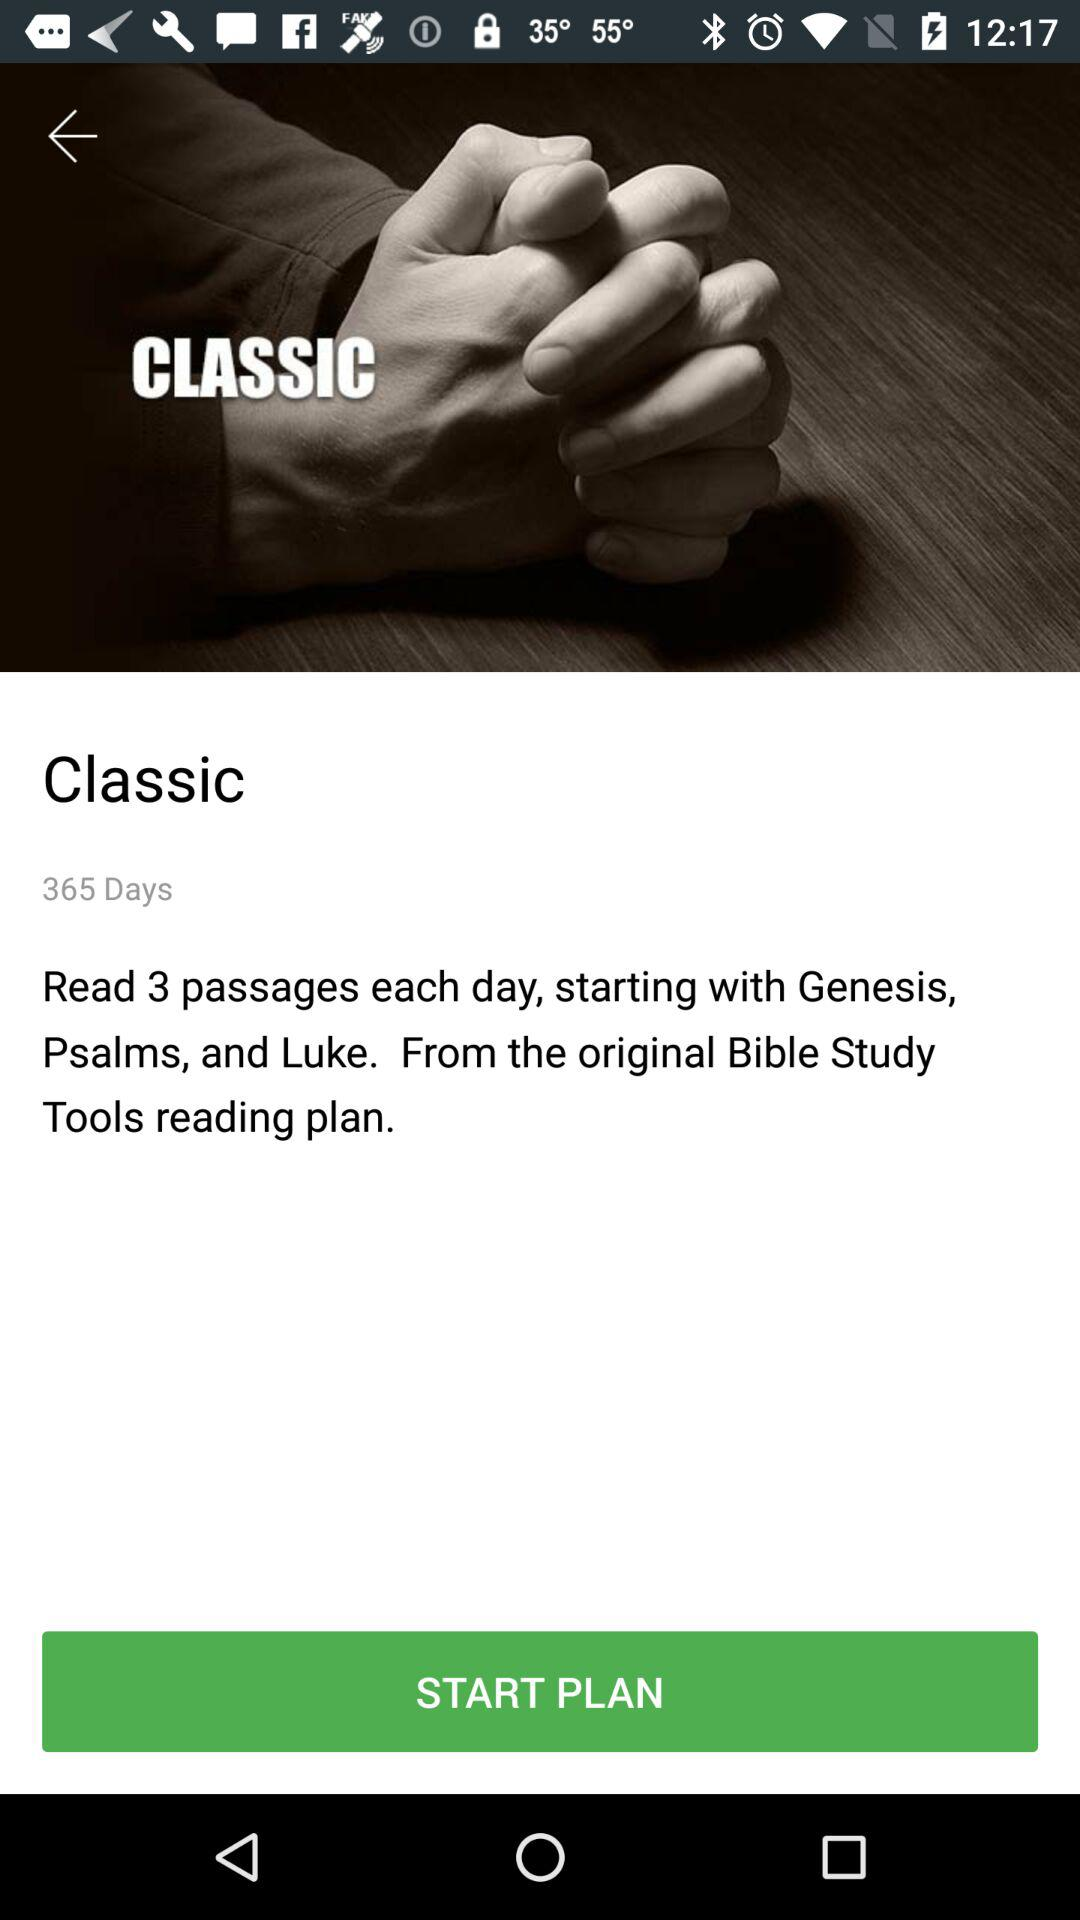How many passages are read each day in the Classic reading plan?
Answer the question using a single word or phrase. 3 